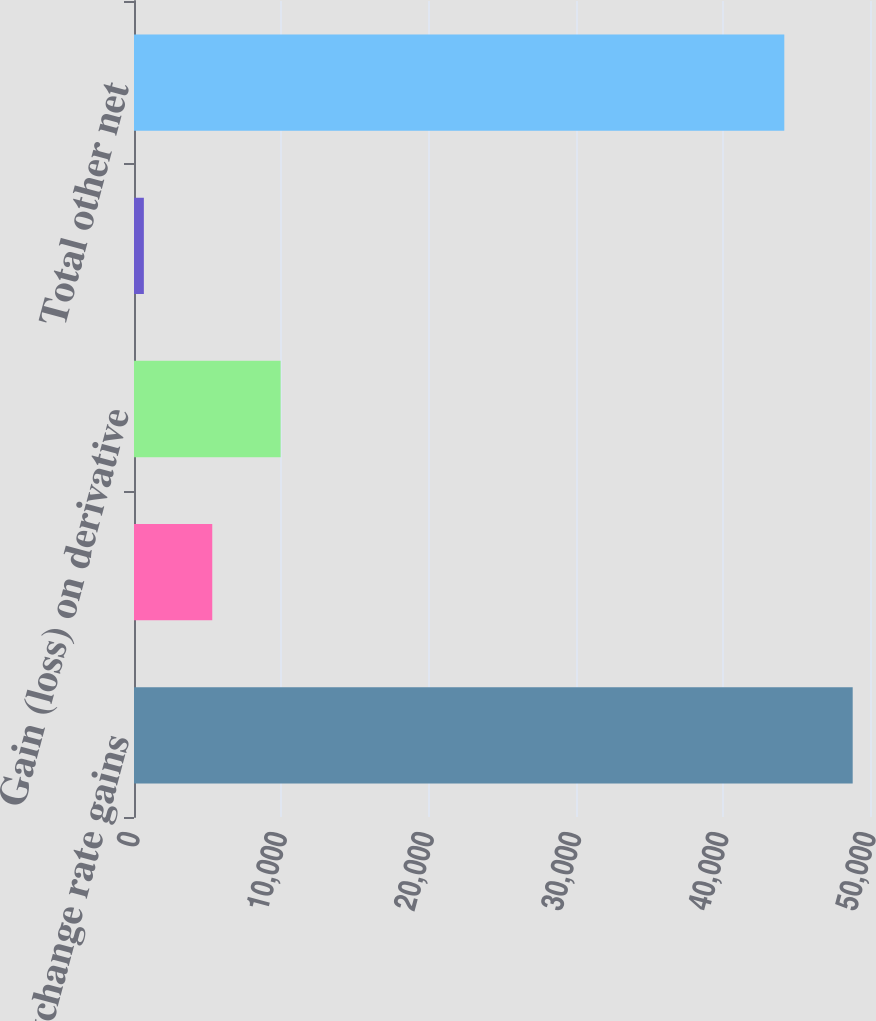Convert chart. <chart><loc_0><loc_0><loc_500><loc_500><bar_chart><fcel>Foreign exchange rate gains<fcel>Equity in gain (loss) of<fcel>Gain (loss) on derivative<fcel>Other<fcel>Total other net<nl><fcel>48823.9<fcel>5315.9<fcel>9961.8<fcel>670<fcel>44178<nl></chart> 